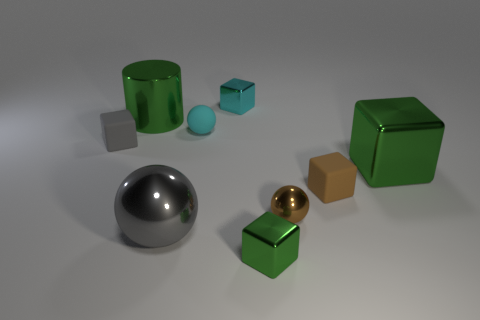Subtract all cyan blocks. How many blocks are left? 4 Subtract all small gray cubes. How many cubes are left? 4 Subtract all red cylinders. Subtract all gray cubes. How many cylinders are left? 1 Subtract all cylinders. How many objects are left? 8 Add 6 large gray spheres. How many large gray spheres are left? 7 Add 1 gray metal objects. How many gray metal objects exist? 2 Subtract 1 cyan cubes. How many objects are left? 8 Subtract all tiny gray cubes. Subtract all cyan objects. How many objects are left? 6 